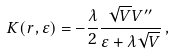<formula> <loc_0><loc_0><loc_500><loc_500>K ( r , \varepsilon ) = - \frac { \lambda } { 2 } \frac { \sqrt { V } V ^ { \prime \prime } } { \varepsilon + \lambda \sqrt { V } } \, ,</formula> 